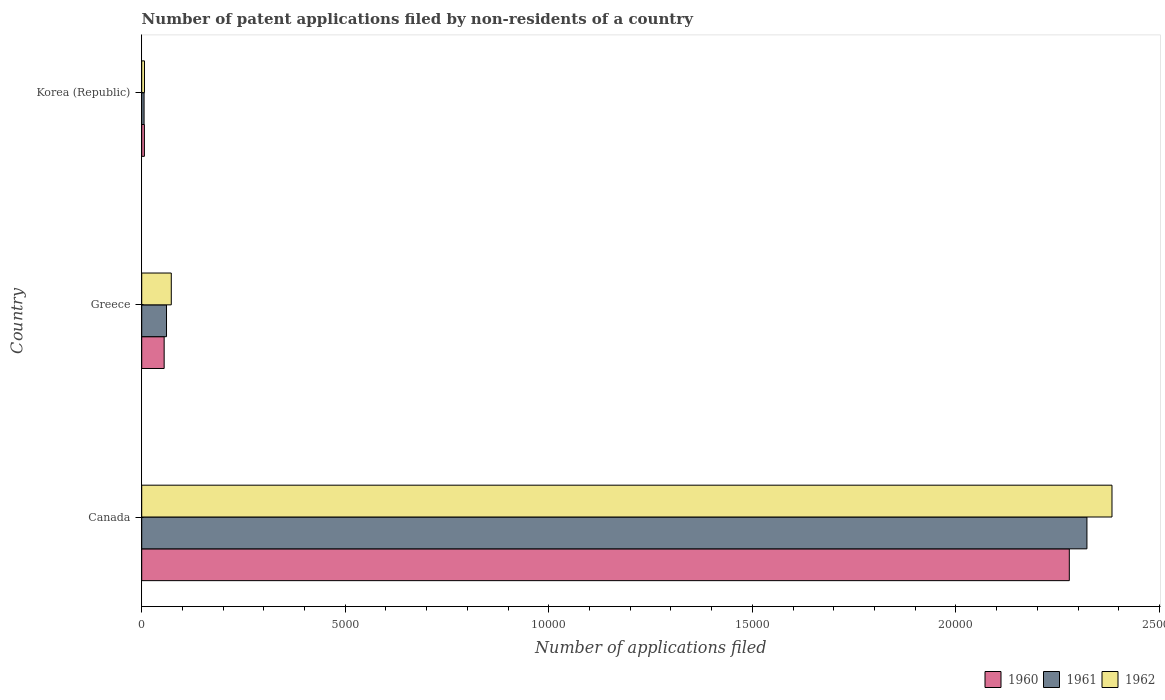How many different coloured bars are there?
Provide a succinct answer. 3. How many groups of bars are there?
Make the answer very short. 3. Are the number of bars on each tick of the Y-axis equal?
Keep it short and to the point. Yes. How many bars are there on the 1st tick from the top?
Keep it short and to the point. 3. What is the label of the 2nd group of bars from the top?
Make the answer very short. Greece. In how many cases, is the number of bars for a given country not equal to the number of legend labels?
Your answer should be very brief. 0. What is the number of applications filed in 1961 in Canada?
Your answer should be compact. 2.32e+04. Across all countries, what is the maximum number of applications filed in 1960?
Your answer should be compact. 2.28e+04. In which country was the number of applications filed in 1962 minimum?
Your response must be concise. Korea (Republic). What is the total number of applications filed in 1960 in the graph?
Provide a succinct answer. 2.34e+04. What is the difference between the number of applications filed in 1960 in Canada and that in Korea (Republic)?
Provide a short and direct response. 2.27e+04. What is the difference between the number of applications filed in 1961 in Canada and the number of applications filed in 1962 in Korea (Republic)?
Give a very brief answer. 2.32e+04. What is the average number of applications filed in 1962 per country?
Offer a very short reply. 8209.33. What is the difference between the number of applications filed in 1961 and number of applications filed in 1962 in Canada?
Provide a succinct answer. -615. In how many countries, is the number of applications filed in 1960 greater than 18000 ?
Give a very brief answer. 1. What is the ratio of the number of applications filed in 1962 in Greece to that in Korea (Republic)?
Keep it short and to the point. 10.68. Is the difference between the number of applications filed in 1961 in Canada and Korea (Republic) greater than the difference between the number of applications filed in 1962 in Canada and Korea (Republic)?
Your answer should be very brief. No. What is the difference between the highest and the second highest number of applications filed in 1961?
Offer a terse response. 2.26e+04. What is the difference between the highest and the lowest number of applications filed in 1960?
Your response must be concise. 2.27e+04. In how many countries, is the number of applications filed in 1962 greater than the average number of applications filed in 1962 taken over all countries?
Make the answer very short. 1. Is it the case that in every country, the sum of the number of applications filed in 1962 and number of applications filed in 1961 is greater than the number of applications filed in 1960?
Give a very brief answer. Yes. How many bars are there?
Provide a short and direct response. 9. Are all the bars in the graph horizontal?
Your answer should be compact. Yes. Are the values on the major ticks of X-axis written in scientific E-notation?
Your answer should be very brief. No. Where does the legend appear in the graph?
Offer a very short reply. Bottom right. How many legend labels are there?
Make the answer very short. 3. How are the legend labels stacked?
Your answer should be very brief. Horizontal. What is the title of the graph?
Give a very brief answer. Number of patent applications filed by non-residents of a country. Does "1965" appear as one of the legend labels in the graph?
Offer a very short reply. No. What is the label or title of the X-axis?
Give a very brief answer. Number of applications filed. What is the label or title of the Y-axis?
Your answer should be very brief. Country. What is the Number of applications filed in 1960 in Canada?
Make the answer very short. 2.28e+04. What is the Number of applications filed of 1961 in Canada?
Provide a succinct answer. 2.32e+04. What is the Number of applications filed of 1962 in Canada?
Provide a succinct answer. 2.38e+04. What is the Number of applications filed of 1960 in Greece?
Offer a terse response. 551. What is the Number of applications filed of 1961 in Greece?
Provide a succinct answer. 609. What is the Number of applications filed in 1962 in Greece?
Keep it short and to the point. 726. What is the Number of applications filed in 1960 in Korea (Republic)?
Ensure brevity in your answer.  66. What is the Number of applications filed in 1961 in Korea (Republic)?
Offer a very short reply. 58. What is the Number of applications filed of 1962 in Korea (Republic)?
Provide a short and direct response. 68. Across all countries, what is the maximum Number of applications filed in 1960?
Give a very brief answer. 2.28e+04. Across all countries, what is the maximum Number of applications filed of 1961?
Offer a terse response. 2.32e+04. Across all countries, what is the maximum Number of applications filed in 1962?
Offer a very short reply. 2.38e+04. Across all countries, what is the minimum Number of applications filed in 1960?
Keep it short and to the point. 66. What is the total Number of applications filed in 1960 in the graph?
Provide a short and direct response. 2.34e+04. What is the total Number of applications filed in 1961 in the graph?
Offer a terse response. 2.39e+04. What is the total Number of applications filed of 1962 in the graph?
Keep it short and to the point. 2.46e+04. What is the difference between the Number of applications filed in 1960 in Canada and that in Greece?
Provide a short and direct response. 2.22e+04. What is the difference between the Number of applications filed in 1961 in Canada and that in Greece?
Keep it short and to the point. 2.26e+04. What is the difference between the Number of applications filed of 1962 in Canada and that in Greece?
Your answer should be compact. 2.31e+04. What is the difference between the Number of applications filed of 1960 in Canada and that in Korea (Republic)?
Offer a very short reply. 2.27e+04. What is the difference between the Number of applications filed in 1961 in Canada and that in Korea (Republic)?
Provide a short and direct response. 2.32e+04. What is the difference between the Number of applications filed in 1962 in Canada and that in Korea (Republic)?
Give a very brief answer. 2.38e+04. What is the difference between the Number of applications filed in 1960 in Greece and that in Korea (Republic)?
Give a very brief answer. 485. What is the difference between the Number of applications filed in 1961 in Greece and that in Korea (Republic)?
Your answer should be compact. 551. What is the difference between the Number of applications filed of 1962 in Greece and that in Korea (Republic)?
Ensure brevity in your answer.  658. What is the difference between the Number of applications filed in 1960 in Canada and the Number of applications filed in 1961 in Greece?
Your response must be concise. 2.22e+04. What is the difference between the Number of applications filed in 1960 in Canada and the Number of applications filed in 1962 in Greece?
Offer a very short reply. 2.21e+04. What is the difference between the Number of applications filed in 1961 in Canada and the Number of applications filed in 1962 in Greece?
Provide a succinct answer. 2.25e+04. What is the difference between the Number of applications filed in 1960 in Canada and the Number of applications filed in 1961 in Korea (Republic)?
Your answer should be compact. 2.27e+04. What is the difference between the Number of applications filed of 1960 in Canada and the Number of applications filed of 1962 in Korea (Republic)?
Provide a short and direct response. 2.27e+04. What is the difference between the Number of applications filed of 1961 in Canada and the Number of applications filed of 1962 in Korea (Republic)?
Make the answer very short. 2.32e+04. What is the difference between the Number of applications filed in 1960 in Greece and the Number of applications filed in 1961 in Korea (Republic)?
Your answer should be very brief. 493. What is the difference between the Number of applications filed of 1960 in Greece and the Number of applications filed of 1962 in Korea (Republic)?
Offer a very short reply. 483. What is the difference between the Number of applications filed in 1961 in Greece and the Number of applications filed in 1962 in Korea (Republic)?
Your answer should be compact. 541. What is the average Number of applications filed of 1960 per country?
Your answer should be compact. 7801. What is the average Number of applications filed in 1961 per country?
Your answer should be compact. 7962. What is the average Number of applications filed in 1962 per country?
Your response must be concise. 8209.33. What is the difference between the Number of applications filed of 1960 and Number of applications filed of 1961 in Canada?
Offer a very short reply. -433. What is the difference between the Number of applications filed in 1960 and Number of applications filed in 1962 in Canada?
Your answer should be compact. -1048. What is the difference between the Number of applications filed of 1961 and Number of applications filed of 1962 in Canada?
Keep it short and to the point. -615. What is the difference between the Number of applications filed of 1960 and Number of applications filed of 1961 in Greece?
Give a very brief answer. -58. What is the difference between the Number of applications filed in 1960 and Number of applications filed in 1962 in Greece?
Your answer should be very brief. -175. What is the difference between the Number of applications filed of 1961 and Number of applications filed of 1962 in Greece?
Offer a terse response. -117. What is the difference between the Number of applications filed of 1960 and Number of applications filed of 1962 in Korea (Republic)?
Your response must be concise. -2. What is the difference between the Number of applications filed in 1961 and Number of applications filed in 1962 in Korea (Republic)?
Your answer should be very brief. -10. What is the ratio of the Number of applications filed in 1960 in Canada to that in Greece?
Ensure brevity in your answer.  41.35. What is the ratio of the Number of applications filed of 1961 in Canada to that in Greece?
Offer a terse response. 38.13. What is the ratio of the Number of applications filed in 1962 in Canada to that in Greece?
Keep it short and to the point. 32.83. What is the ratio of the Number of applications filed of 1960 in Canada to that in Korea (Republic)?
Keep it short and to the point. 345.24. What is the ratio of the Number of applications filed in 1961 in Canada to that in Korea (Republic)?
Your answer should be compact. 400.33. What is the ratio of the Number of applications filed in 1962 in Canada to that in Korea (Republic)?
Offer a terse response. 350.5. What is the ratio of the Number of applications filed in 1960 in Greece to that in Korea (Republic)?
Make the answer very short. 8.35. What is the ratio of the Number of applications filed in 1962 in Greece to that in Korea (Republic)?
Provide a short and direct response. 10.68. What is the difference between the highest and the second highest Number of applications filed of 1960?
Your answer should be very brief. 2.22e+04. What is the difference between the highest and the second highest Number of applications filed in 1961?
Your answer should be compact. 2.26e+04. What is the difference between the highest and the second highest Number of applications filed in 1962?
Ensure brevity in your answer.  2.31e+04. What is the difference between the highest and the lowest Number of applications filed of 1960?
Make the answer very short. 2.27e+04. What is the difference between the highest and the lowest Number of applications filed of 1961?
Your response must be concise. 2.32e+04. What is the difference between the highest and the lowest Number of applications filed of 1962?
Offer a very short reply. 2.38e+04. 